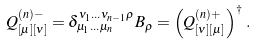<formula> <loc_0><loc_0><loc_500><loc_500>Q ^ { ( n ) - } _ { [ \mu ] [ \nu ] } = \delta _ { \mu _ { 1 } \dots \mu _ { n } } ^ { \nu _ { 1 } \dots \nu _ { n - 1 } \rho } B _ { \rho } = \left ( Q ^ { ( n ) + } _ { [ \nu ] [ \mu ] } \right ) ^ { \dag } \, .</formula> 